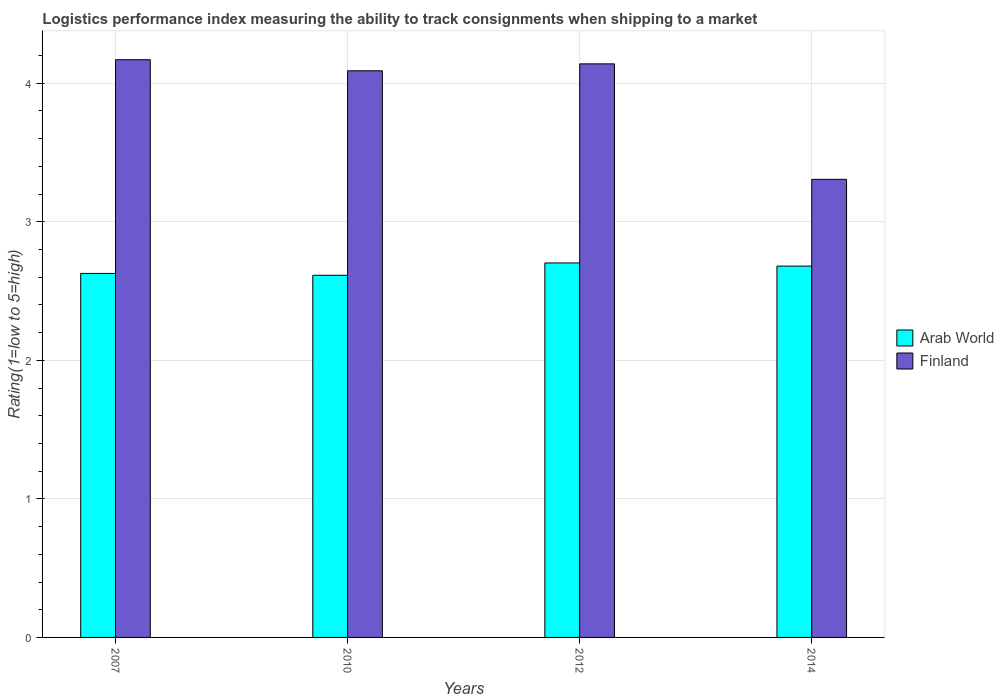Are the number of bars on each tick of the X-axis equal?
Offer a very short reply. Yes. How many bars are there on the 2nd tick from the left?
Your answer should be very brief. 2. How many bars are there on the 3rd tick from the right?
Offer a terse response. 2. What is the label of the 2nd group of bars from the left?
Provide a short and direct response. 2010. In how many cases, is the number of bars for a given year not equal to the number of legend labels?
Your answer should be compact. 0. What is the Logistic performance index in Arab World in 2012?
Offer a very short reply. 2.7. Across all years, what is the maximum Logistic performance index in Finland?
Your answer should be very brief. 4.17. Across all years, what is the minimum Logistic performance index in Arab World?
Provide a short and direct response. 2.61. In which year was the Logistic performance index in Arab World maximum?
Provide a short and direct response. 2012. In which year was the Logistic performance index in Arab World minimum?
Ensure brevity in your answer.  2010. What is the total Logistic performance index in Finland in the graph?
Your answer should be compact. 15.71. What is the difference between the Logistic performance index in Finland in 2010 and that in 2014?
Offer a terse response. 0.78. What is the difference between the Logistic performance index in Arab World in 2010 and the Logistic performance index in Finland in 2012?
Offer a very short reply. -1.53. What is the average Logistic performance index in Arab World per year?
Your response must be concise. 2.66. In the year 2014, what is the difference between the Logistic performance index in Finland and Logistic performance index in Arab World?
Make the answer very short. 0.63. What is the ratio of the Logistic performance index in Arab World in 2007 to that in 2010?
Provide a short and direct response. 1.01. Is the Logistic performance index in Arab World in 2007 less than that in 2012?
Give a very brief answer. Yes. Is the difference between the Logistic performance index in Finland in 2012 and 2014 greater than the difference between the Logistic performance index in Arab World in 2012 and 2014?
Offer a very short reply. Yes. What is the difference between the highest and the second highest Logistic performance index in Finland?
Ensure brevity in your answer.  0.03. What is the difference between the highest and the lowest Logistic performance index in Finland?
Offer a very short reply. 0.86. In how many years, is the Logistic performance index in Arab World greater than the average Logistic performance index in Arab World taken over all years?
Provide a short and direct response. 2. Is the sum of the Logistic performance index in Finland in 2007 and 2010 greater than the maximum Logistic performance index in Arab World across all years?
Offer a terse response. Yes. What does the 1st bar from the left in 2014 represents?
Provide a short and direct response. Arab World. What does the 2nd bar from the right in 2010 represents?
Your response must be concise. Arab World. How many bars are there?
Provide a succinct answer. 8. What is the difference between two consecutive major ticks on the Y-axis?
Offer a very short reply. 1. Does the graph contain any zero values?
Your response must be concise. No. Does the graph contain grids?
Keep it short and to the point. Yes. Where does the legend appear in the graph?
Your answer should be compact. Center right. How many legend labels are there?
Provide a succinct answer. 2. What is the title of the graph?
Make the answer very short. Logistics performance index measuring the ability to track consignments when shipping to a market. Does "Sub-Saharan Africa (developing only)" appear as one of the legend labels in the graph?
Your answer should be very brief. No. What is the label or title of the Y-axis?
Offer a very short reply. Rating(1=low to 5=high). What is the Rating(1=low to 5=high) in Arab World in 2007?
Offer a terse response. 2.63. What is the Rating(1=low to 5=high) in Finland in 2007?
Your answer should be very brief. 4.17. What is the Rating(1=low to 5=high) in Arab World in 2010?
Your answer should be very brief. 2.61. What is the Rating(1=low to 5=high) of Finland in 2010?
Give a very brief answer. 4.09. What is the Rating(1=low to 5=high) in Arab World in 2012?
Offer a terse response. 2.7. What is the Rating(1=low to 5=high) in Finland in 2012?
Your answer should be compact. 4.14. What is the Rating(1=low to 5=high) in Arab World in 2014?
Provide a short and direct response. 2.68. What is the Rating(1=low to 5=high) in Finland in 2014?
Offer a very short reply. 3.31. Across all years, what is the maximum Rating(1=low to 5=high) in Arab World?
Offer a very short reply. 2.7. Across all years, what is the maximum Rating(1=low to 5=high) of Finland?
Offer a very short reply. 4.17. Across all years, what is the minimum Rating(1=low to 5=high) in Arab World?
Your answer should be very brief. 2.61. Across all years, what is the minimum Rating(1=low to 5=high) in Finland?
Your answer should be compact. 3.31. What is the total Rating(1=low to 5=high) in Arab World in the graph?
Your response must be concise. 10.62. What is the total Rating(1=low to 5=high) of Finland in the graph?
Provide a short and direct response. 15.71. What is the difference between the Rating(1=low to 5=high) of Arab World in 2007 and that in 2010?
Provide a short and direct response. 0.01. What is the difference between the Rating(1=low to 5=high) of Finland in 2007 and that in 2010?
Offer a very short reply. 0.08. What is the difference between the Rating(1=low to 5=high) of Arab World in 2007 and that in 2012?
Your response must be concise. -0.08. What is the difference between the Rating(1=low to 5=high) of Finland in 2007 and that in 2012?
Ensure brevity in your answer.  0.03. What is the difference between the Rating(1=low to 5=high) in Arab World in 2007 and that in 2014?
Your answer should be very brief. -0.05. What is the difference between the Rating(1=low to 5=high) in Finland in 2007 and that in 2014?
Provide a short and direct response. 0.86. What is the difference between the Rating(1=low to 5=high) in Arab World in 2010 and that in 2012?
Provide a succinct answer. -0.09. What is the difference between the Rating(1=low to 5=high) of Arab World in 2010 and that in 2014?
Provide a succinct answer. -0.07. What is the difference between the Rating(1=low to 5=high) in Finland in 2010 and that in 2014?
Give a very brief answer. 0.78. What is the difference between the Rating(1=low to 5=high) in Arab World in 2012 and that in 2014?
Your answer should be very brief. 0.02. What is the difference between the Rating(1=low to 5=high) of Finland in 2012 and that in 2014?
Your answer should be compact. 0.83. What is the difference between the Rating(1=low to 5=high) in Arab World in 2007 and the Rating(1=low to 5=high) in Finland in 2010?
Provide a succinct answer. -1.46. What is the difference between the Rating(1=low to 5=high) in Arab World in 2007 and the Rating(1=low to 5=high) in Finland in 2012?
Your answer should be compact. -1.51. What is the difference between the Rating(1=low to 5=high) of Arab World in 2007 and the Rating(1=low to 5=high) of Finland in 2014?
Make the answer very short. -0.68. What is the difference between the Rating(1=low to 5=high) in Arab World in 2010 and the Rating(1=low to 5=high) in Finland in 2012?
Offer a terse response. -1.53. What is the difference between the Rating(1=low to 5=high) of Arab World in 2010 and the Rating(1=low to 5=high) of Finland in 2014?
Make the answer very short. -0.69. What is the difference between the Rating(1=low to 5=high) of Arab World in 2012 and the Rating(1=low to 5=high) of Finland in 2014?
Your answer should be very brief. -0.6. What is the average Rating(1=low to 5=high) of Arab World per year?
Keep it short and to the point. 2.66. What is the average Rating(1=low to 5=high) in Finland per year?
Give a very brief answer. 3.93. In the year 2007, what is the difference between the Rating(1=low to 5=high) in Arab World and Rating(1=low to 5=high) in Finland?
Your response must be concise. -1.54. In the year 2010, what is the difference between the Rating(1=low to 5=high) in Arab World and Rating(1=low to 5=high) in Finland?
Offer a very short reply. -1.48. In the year 2012, what is the difference between the Rating(1=low to 5=high) of Arab World and Rating(1=low to 5=high) of Finland?
Ensure brevity in your answer.  -1.44. In the year 2014, what is the difference between the Rating(1=low to 5=high) of Arab World and Rating(1=low to 5=high) of Finland?
Your answer should be compact. -0.63. What is the ratio of the Rating(1=low to 5=high) of Arab World in 2007 to that in 2010?
Ensure brevity in your answer.  1. What is the ratio of the Rating(1=low to 5=high) of Finland in 2007 to that in 2010?
Provide a short and direct response. 1.02. What is the ratio of the Rating(1=low to 5=high) of Arab World in 2007 to that in 2014?
Your answer should be very brief. 0.98. What is the ratio of the Rating(1=low to 5=high) in Finland in 2007 to that in 2014?
Keep it short and to the point. 1.26. What is the ratio of the Rating(1=low to 5=high) of Arab World in 2010 to that in 2012?
Keep it short and to the point. 0.97. What is the ratio of the Rating(1=low to 5=high) of Finland in 2010 to that in 2012?
Your answer should be compact. 0.99. What is the ratio of the Rating(1=low to 5=high) in Arab World in 2010 to that in 2014?
Your answer should be compact. 0.98. What is the ratio of the Rating(1=low to 5=high) of Finland in 2010 to that in 2014?
Provide a succinct answer. 1.24. What is the ratio of the Rating(1=low to 5=high) of Arab World in 2012 to that in 2014?
Your answer should be compact. 1.01. What is the ratio of the Rating(1=low to 5=high) of Finland in 2012 to that in 2014?
Your answer should be very brief. 1.25. What is the difference between the highest and the second highest Rating(1=low to 5=high) in Arab World?
Make the answer very short. 0.02. What is the difference between the highest and the second highest Rating(1=low to 5=high) in Finland?
Offer a terse response. 0.03. What is the difference between the highest and the lowest Rating(1=low to 5=high) of Arab World?
Offer a terse response. 0.09. What is the difference between the highest and the lowest Rating(1=low to 5=high) of Finland?
Keep it short and to the point. 0.86. 